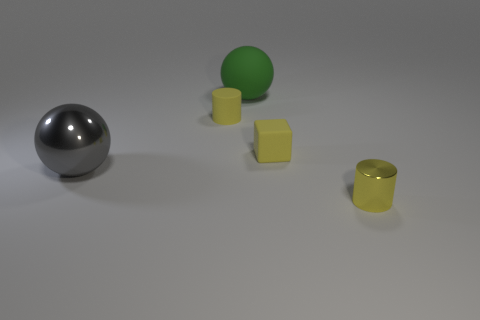Add 1 tiny yellow blocks. How many objects exist? 6 Subtract all balls. How many objects are left? 3 Subtract 1 balls. How many balls are left? 1 Subtract all green cubes. How many gray balls are left? 1 Add 3 tiny matte cylinders. How many tiny matte cylinders exist? 4 Subtract 1 gray balls. How many objects are left? 4 Subtract all green blocks. Subtract all blue cylinders. How many blocks are left? 1 Subtract all large matte things. Subtract all rubber spheres. How many objects are left? 3 Add 4 big gray shiny things. How many big gray shiny things are left? 5 